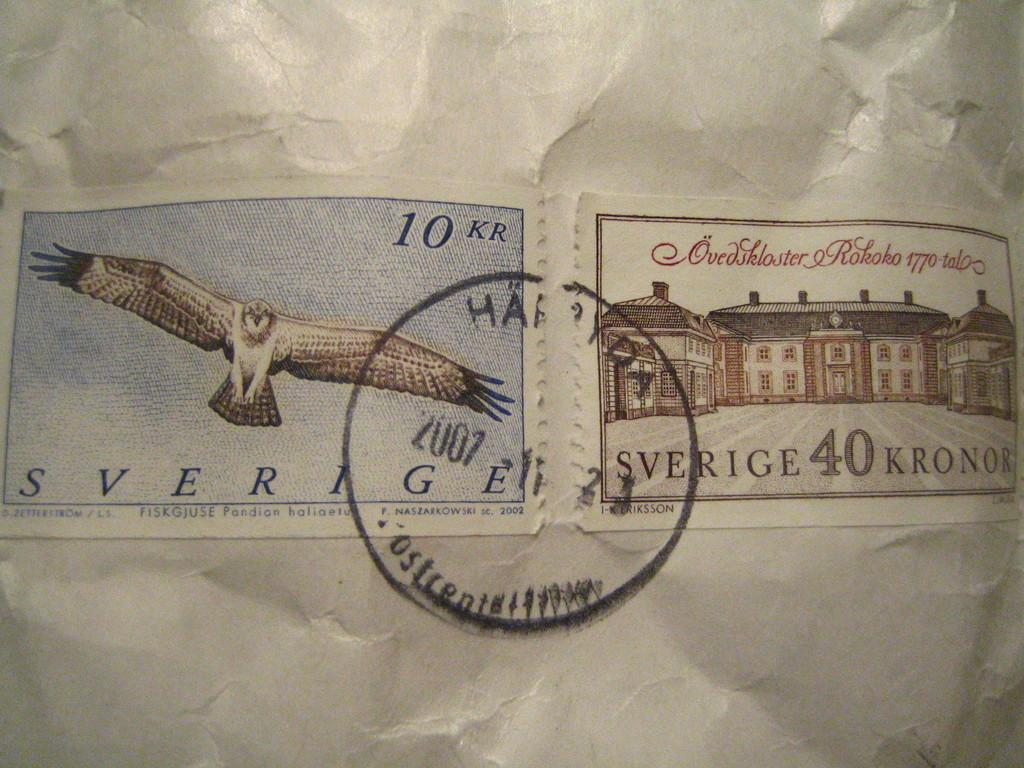What is the main subject of the image? The main subject of the image is two stamp papers with stamps on them. What is the stamp papers attached to? The stamp papers are attached to a white color paper. Where are the stamp papers and the white color paper located in the image? The stamp papers and the white color paper are in the middle of the image. What type of cave can be seen in the background of the image? There is no cave present in the image; it only features stamp papers and a white color paper. 